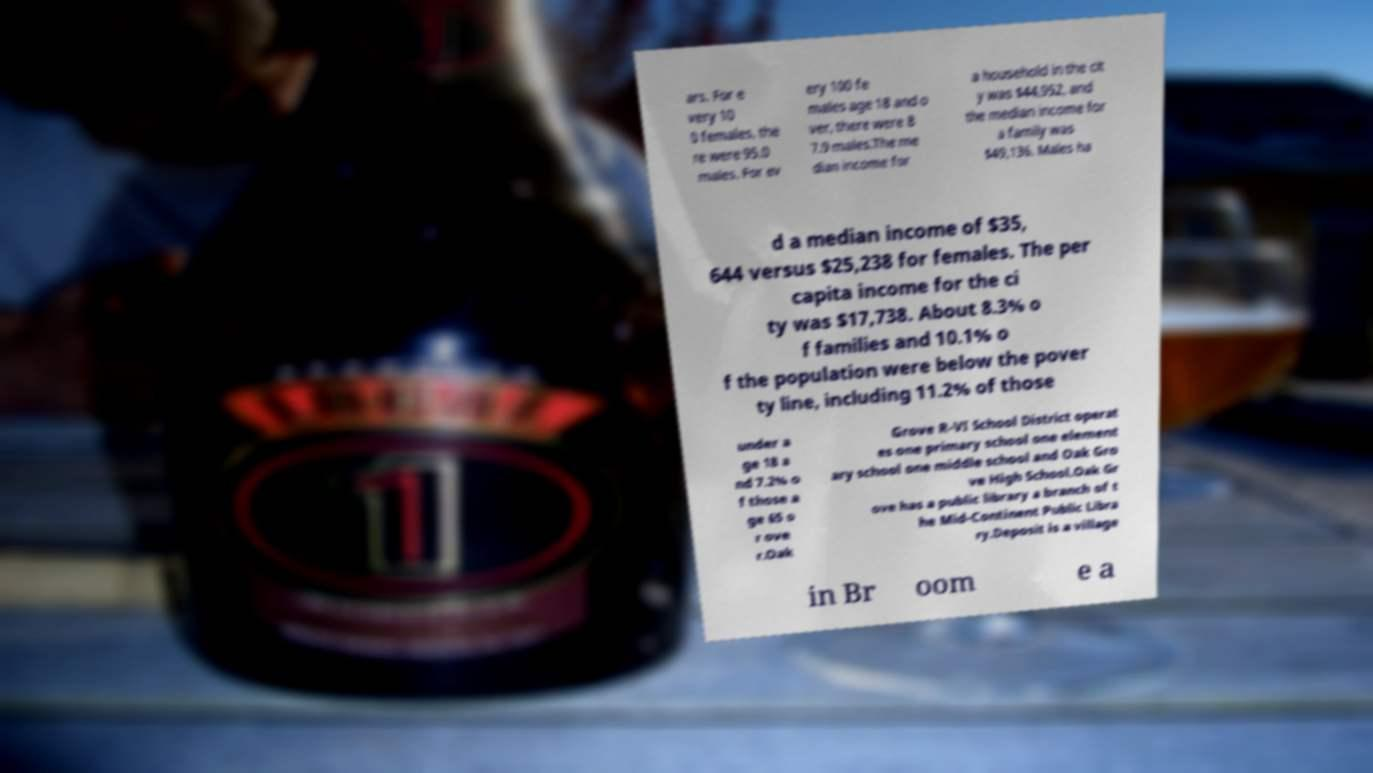Can you accurately transcribe the text from the provided image for me? ars. For e very 10 0 females, the re were 95.0 males. For ev ery 100 fe males age 18 and o ver, there were 8 7.9 males.The me dian income for a household in the cit y was $44,952, and the median income for a family was $49,136. Males ha d a median income of $35, 644 versus $25,238 for females. The per capita income for the ci ty was $17,738. About 8.3% o f families and 10.1% o f the population were below the pover ty line, including 11.2% of those under a ge 18 a nd 7.2% o f those a ge 65 o r ove r.Oak Grove R-VI School District operat es one primary school one element ary school one middle school and Oak Gro ve High School.Oak Gr ove has a public library a branch of t he Mid-Continent Public Libra ry.Deposit is a village in Br oom e a 